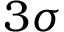<formula> <loc_0><loc_0><loc_500><loc_500>3 \sigma</formula> 